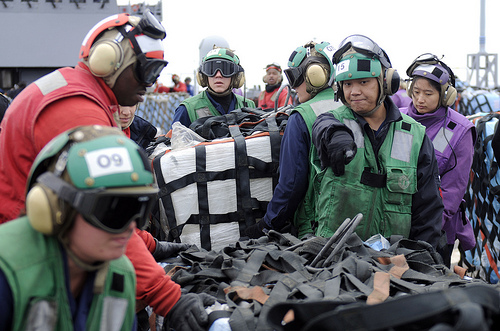<image>
Is the belt in front of the person? Yes. The belt is positioned in front of the person, appearing closer to the camera viewpoint. 